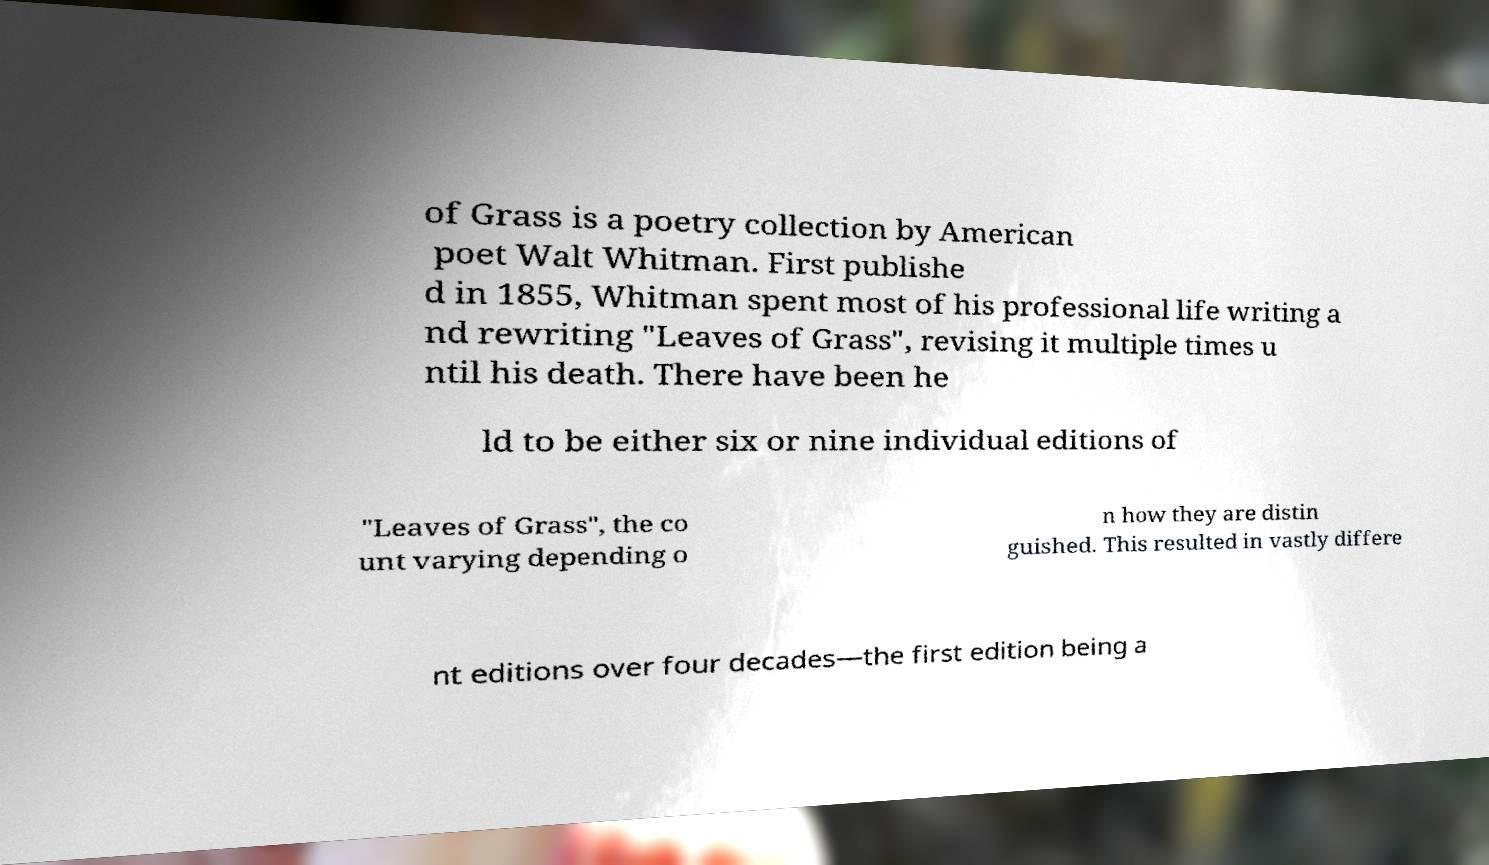What messages or text are displayed in this image? I need them in a readable, typed format. of Grass is a poetry collection by American poet Walt Whitman. First publishe d in 1855, Whitman spent most of his professional life writing a nd rewriting "Leaves of Grass", revising it multiple times u ntil his death. There have been he ld to be either six or nine individual editions of "Leaves of Grass", the co unt varying depending o n how they are distin guished. This resulted in vastly differe nt editions over four decades—the first edition being a 